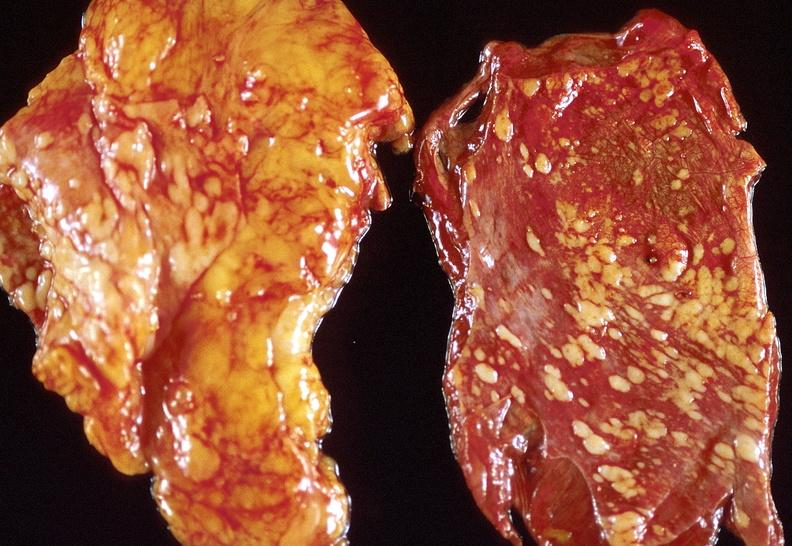s respiratory present?
Answer the question using a single word or phrase. Yes 